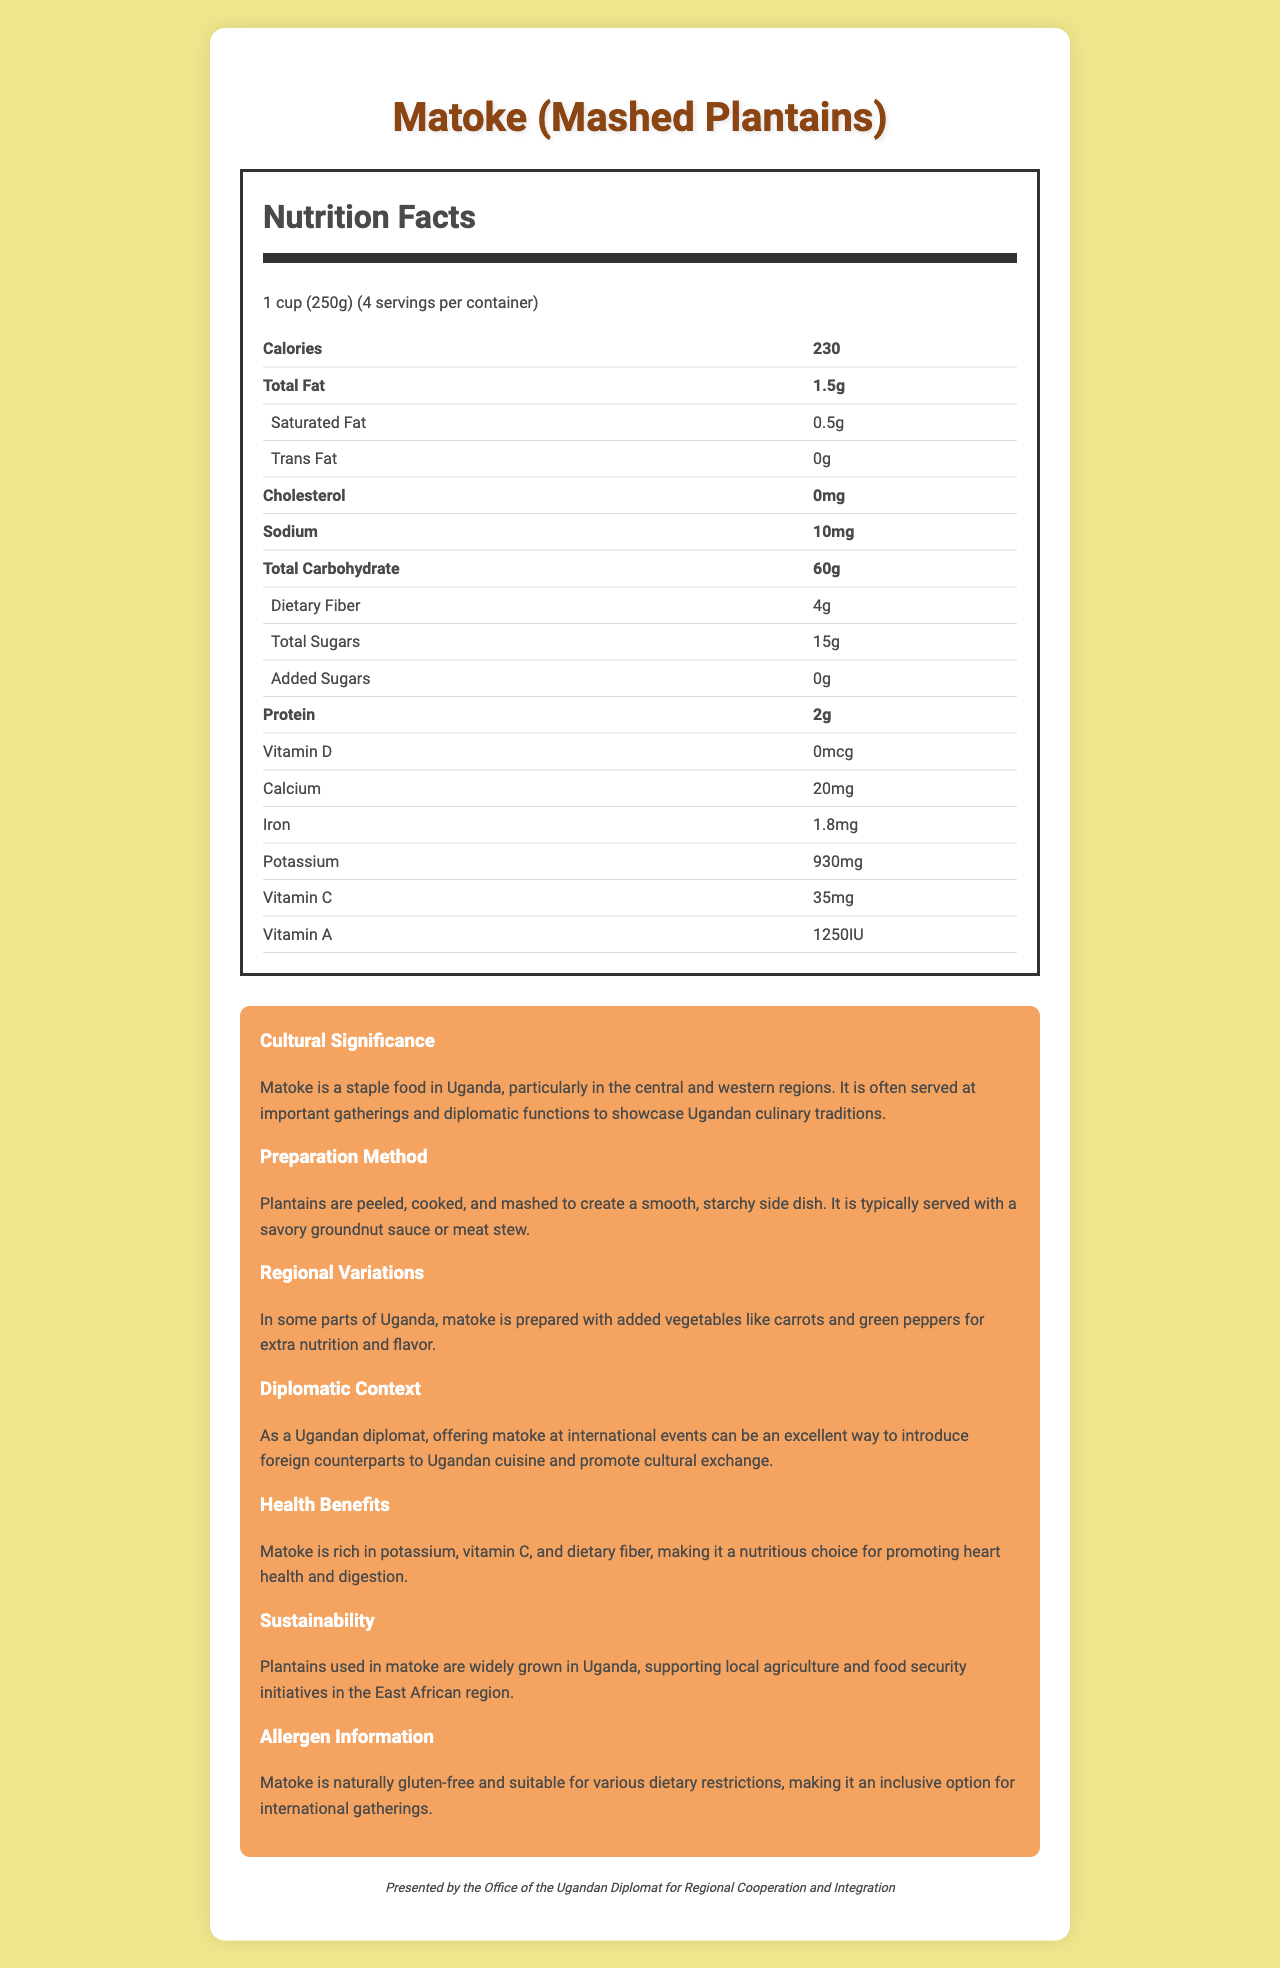what is the serving size? The serving size is specified at the beginning of the Nutrition Facts, which states "1 cup (250g)".
Answer: 1 cup (250g) how many calories are in one serving of Matoke? The number of calories per serving is listed at the top of the Nutrition Facts section as "Calories: 230".
Answer: 230 calories what is the total carbohydrate content in one serving? The total carbohydrate content is provided in the Nutrition Facts area under "Total Carbohydrate".
Answer: 60g how much potassium is in one serving of Matoke? The potassium content is mentioned towards the bottom of the list in the Nutrition Facts section.
Answer: 930mg is Matoke gluten-free? The allergen information states that Matoke is naturally gluten-free.
Answer: Yes what is Matoke traditionally served with? A. On its own B. With a savory groundnut sauce or meat stew C. With sugary toppings D. Deep-fried The preparation method section mentions that Matoke is typically served with a savory groundnut sauce or meat stew.
Answer: B what is one of the health benefits of Matoke? A. High in protein B. Rich in Vitamin D C. Promotes heart health and digestion D. Low in calories One of the health benefits mentioned is that Matoke is rich in potassium, vitamin C, and dietary fiber, which contribute to heart health and digestion.
Answer: C does Matoke have any added sugars? The Nutrition Facts indicate that the total sugars include 0g of added sugars.
Answer: No how is Matoke prepared? The preparation method specifies that plantains are peeled, cooked, and mashed to create a smooth, starchy side dish.
Answer: Plantains are peeled, cooked, and mashed what is the main idea of the document? The document combines nutrition facts with cultural and health-related information, aiming to present Matoke as a nutritious and significant dish suitable for diplomatic contexts.
Answer: The document describes the nutritional content, cultural significance, preparation, and health benefits of Matoke, a traditional Ugandan dish, highlighting its potential for promoting cultural exchange and inclusivity at international gatherings. how many grams of protein are in one serving of Matoke? The protein content is listed in the Nutrition Facts as 2g per serving.
Answer: 2g can you determine how plantains are sourced for Matoke from this document? While the document mentions that plantains are widely grown in Uganda, it does not provide specific details on sourcing practices.
Answer: Not enough information how often is Matoke served at diplomatic functions? The document states that Matoke is often served at important gatherings and diplomatic functions but does not specify the frequency.
Answer: Cannot be determined what is one regional variation of Matoke mentioned in the document? The regional variations section mentions that in some parts of Uganda, Matoke is prepared with added vegetables for extra nutrition and flavor.
Answer: Adding vegetables like carrots and green peppers 